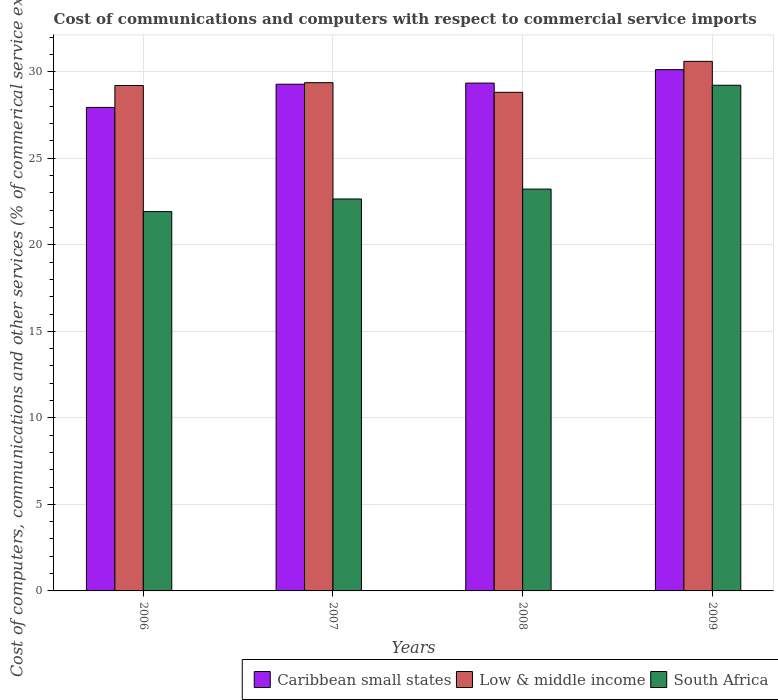Are the number of bars per tick equal to the number of legend labels?
Keep it short and to the point. Yes. Are the number of bars on each tick of the X-axis equal?
Make the answer very short. Yes. How many bars are there on the 1st tick from the left?
Ensure brevity in your answer.  3. How many bars are there on the 2nd tick from the right?
Your response must be concise. 3. What is the cost of communications and computers in South Africa in 2008?
Keep it short and to the point. 23.22. Across all years, what is the maximum cost of communications and computers in Low & middle income?
Provide a short and direct response. 30.6. Across all years, what is the minimum cost of communications and computers in South Africa?
Provide a short and direct response. 21.92. In which year was the cost of communications and computers in Caribbean small states maximum?
Offer a very short reply. 2009. What is the total cost of communications and computers in Caribbean small states in the graph?
Offer a very short reply. 116.67. What is the difference between the cost of communications and computers in Low & middle income in 2007 and that in 2009?
Your response must be concise. -1.23. What is the difference between the cost of communications and computers in Low & middle income in 2008 and the cost of communications and computers in South Africa in 2009?
Provide a succinct answer. -0.41. What is the average cost of communications and computers in Caribbean small states per year?
Offer a very short reply. 29.17. In the year 2009, what is the difference between the cost of communications and computers in Caribbean small states and cost of communications and computers in South Africa?
Your response must be concise. 0.9. In how many years, is the cost of communications and computers in Low & middle income greater than 15 %?
Provide a succinct answer. 4. What is the ratio of the cost of communications and computers in Low & middle income in 2007 to that in 2008?
Provide a succinct answer. 1.02. What is the difference between the highest and the second highest cost of communications and computers in South Africa?
Ensure brevity in your answer.  6. What is the difference between the highest and the lowest cost of communications and computers in Low & middle income?
Your answer should be compact. 1.79. What does the 3rd bar from the left in 2008 represents?
Make the answer very short. South Africa. What does the 1st bar from the right in 2007 represents?
Your response must be concise. South Africa. Is it the case that in every year, the sum of the cost of communications and computers in Low & middle income and cost of communications and computers in South Africa is greater than the cost of communications and computers in Caribbean small states?
Offer a very short reply. Yes. How many bars are there?
Keep it short and to the point. 12. Are all the bars in the graph horizontal?
Ensure brevity in your answer.  No. How many years are there in the graph?
Your answer should be compact. 4. What is the difference between two consecutive major ticks on the Y-axis?
Ensure brevity in your answer.  5. Are the values on the major ticks of Y-axis written in scientific E-notation?
Offer a terse response. No. Does the graph contain grids?
Offer a very short reply. Yes. Where does the legend appear in the graph?
Your response must be concise. Bottom right. How many legend labels are there?
Provide a succinct answer. 3. What is the title of the graph?
Offer a terse response. Cost of communications and computers with respect to commercial service imports. Does "Iceland" appear as one of the legend labels in the graph?
Provide a short and direct response. No. What is the label or title of the X-axis?
Your answer should be compact. Years. What is the label or title of the Y-axis?
Your answer should be very brief. Cost of computers, communications and other services (% of commerical service exports). What is the Cost of computers, communications and other services (% of commerical service exports) in Caribbean small states in 2006?
Your response must be concise. 27.94. What is the Cost of computers, communications and other services (% of commerical service exports) of Low & middle income in 2006?
Provide a succinct answer. 29.2. What is the Cost of computers, communications and other services (% of commerical service exports) in South Africa in 2006?
Give a very brief answer. 21.92. What is the Cost of computers, communications and other services (% of commerical service exports) of Caribbean small states in 2007?
Your response must be concise. 29.28. What is the Cost of computers, communications and other services (% of commerical service exports) of Low & middle income in 2007?
Ensure brevity in your answer.  29.37. What is the Cost of computers, communications and other services (% of commerical service exports) of South Africa in 2007?
Give a very brief answer. 22.65. What is the Cost of computers, communications and other services (% of commerical service exports) of Caribbean small states in 2008?
Give a very brief answer. 29.34. What is the Cost of computers, communications and other services (% of commerical service exports) in Low & middle income in 2008?
Keep it short and to the point. 28.81. What is the Cost of computers, communications and other services (% of commerical service exports) of South Africa in 2008?
Provide a succinct answer. 23.22. What is the Cost of computers, communications and other services (% of commerical service exports) in Caribbean small states in 2009?
Give a very brief answer. 30.12. What is the Cost of computers, communications and other services (% of commerical service exports) in Low & middle income in 2009?
Your answer should be compact. 30.6. What is the Cost of computers, communications and other services (% of commerical service exports) of South Africa in 2009?
Your answer should be compact. 29.22. Across all years, what is the maximum Cost of computers, communications and other services (% of commerical service exports) in Caribbean small states?
Provide a short and direct response. 30.12. Across all years, what is the maximum Cost of computers, communications and other services (% of commerical service exports) of Low & middle income?
Your response must be concise. 30.6. Across all years, what is the maximum Cost of computers, communications and other services (% of commerical service exports) in South Africa?
Offer a very short reply. 29.22. Across all years, what is the minimum Cost of computers, communications and other services (% of commerical service exports) of Caribbean small states?
Your answer should be compact. 27.94. Across all years, what is the minimum Cost of computers, communications and other services (% of commerical service exports) in Low & middle income?
Your answer should be compact. 28.81. Across all years, what is the minimum Cost of computers, communications and other services (% of commerical service exports) of South Africa?
Make the answer very short. 21.92. What is the total Cost of computers, communications and other services (% of commerical service exports) of Caribbean small states in the graph?
Your answer should be compact. 116.67. What is the total Cost of computers, communications and other services (% of commerical service exports) in Low & middle income in the graph?
Provide a short and direct response. 117.97. What is the total Cost of computers, communications and other services (% of commerical service exports) of South Africa in the graph?
Make the answer very short. 97. What is the difference between the Cost of computers, communications and other services (% of commerical service exports) of Caribbean small states in 2006 and that in 2007?
Offer a terse response. -1.34. What is the difference between the Cost of computers, communications and other services (% of commerical service exports) in Low & middle income in 2006 and that in 2007?
Your response must be concise. -0.16. What is the difference between the Cost of computers, communications and other services (% of commerical service exports) of South Africa in 2006 and that in 2007?
Your response must be concise. -0.73. What is the difference between the Cost of computers, communications and other services (% of commerical service exports) of Caribbean small states in 2006 and that in 2008?
Give a very brief answer. -1.41. What is the difference between the Cost of computers, communications and other services (% of commerical service exports) in Low & middle income in 2006 and that in 2008?
Keep it short and to the point. 0.39. What is the difference between the Cost of computers, communications and other services (% of commerical service exports) of South Africa in 2006 and that in 2008?
Your answer should be compact. -1.3. What is the difference between the Cost of computers, communications and other services (% of commerical service exports) in Caribbean small states in 2006 and that in 2009?
Offer a terse response. -2.18. What is the difference between the Cost of computers, communications and other services (% of commerical service exports) of Low & middle income in 2006 and that in 2009?
Make the answer very short. -1.4. What is the difference between the Cost of computers, communications and other services (% of commerical service exports) of South Africa in 2006 and that in 2009?
Keep it short and to the point. -7.3. What is the difference between the Cost of computers, communications and other services (% of commerical service exports) in Caribbean small states in 2007 and that in 2008?
Your answer should be very brief. -0.06. What is the difference between the Cost of computers, communications and other services (% of commerical service exports) in Low & middle income in 2007 and that in 2008?
Keep it short and to the point. 0.56. What is the difference between the Cost of computers, communications and other services (% of commerical service exports) of South Africa in 2007 and that in 2008?
Provide a succinct answer. -0.57. What is the difference between the Cost of computers, communications and other services (% of commerical service exports) of Caribbean small states in 2007 and that in 2009?
Give a very brief answer. -0.84. What is the difference between the Cost of computers, communications and other services (% of commerical service exports) in Low & middle income in 2007 and that in 2009?
Offer a very short reply. -1.23. What is the difference between the Cost of computers, communications and other services (% of commerical service exports) of South Africa in 2007 and that in 2009?
Your response must be concise. -6.57. What is the difference between the Cost of computers, communications and other services (% of commerical service exports) of Caribbean small states in 2008 and that in 2009?
Your response must be concise. -0.78. What is the difference between the Cost of computers, communications and other services (% of commerical service exports) in Low & middle income in 2008 and that in 2009?
Provide a short and direct response. -1.79. What is the difference between the Cost of computers, communications and other services (% of commerical service exports) of South Africa in 2008 and that in 2009?
Your response must be concise. -6. What is the difference between the Cost of computers, communications and other services (% of commerical service exports) of Caribbean small states in 2006 and the Cost of computers, communications and other services (% of commerical service exports) of Low & middle income in 2007?
Offer a very short reply. -1.43. What is the difference between the Cost of computers, communications and other services (% of commerical service exports) in Caribbean small states in 2006 and the Cost of computers, communications and other services (% of commerical service exports) in South Africa in 2007?
Your answer should be compact. 5.29. What is the difference between the Cost of computers, communications and other services (% of commerical service exports) in Low & middle income in 2006 and the Cost of computers, communications and other services (% of commerical service exports) in South Africa in 2007?
Make the answer very short. 6.56. What is the difference between the Cost of computers, communications and other services (% of commerical service exports) in Caribbean small states in 2006 and the Cost of computers, communications and other services (% of commerical service exports) in Low & middle income in 2008?
Keep it short and to the point. -0.87. What is the difference between the Cost of computers, communications and other services (% of commerical service exports) in Caribbean small states in 2006 and the Cost of computers, communications and other services (% of commerical service exports) in South Africa in 2008?
Provide a short and direct response. 4.72. What is the difference between the Cost of computers, communications and other services (% of commerical service exports) of Low & middle income in 2006 and the Cost of computers, communications and other services (% of commerical service exports) of South Africa in 2008?
Provide a short and direct response. 5.98. What is the difference between the Cost of computers, communications and other services (% of commerical service exports) of Caribbean small states in 2006 and the Cost of computers, communications and other services (% of commerical service exports) of Low & middle income in 2009?
Keep it short and to the point. -2.66. What is the difference between the Cost of computers, communications and other services (% of commerical service exports) of Caribbean small states in 2006 and the Cost of computers, communications and other services (% of commerical service exports) of South Africa in 2009?
Your answer should be compact. -1.28. What is the difference between the Cost of computers, communications and other services (% of commerical service exports) of Low & middle income in 2006 and the Cost of computers, communications and other services (% of commerical service exports) of South Africa in 2009?
Give a very brief answer. -0.02. What is the difference between the Cost of computers, communications and other services (% of commerical service exports) in Caribbean small states in 2007 and the Cost of computers, communications and other services (% of commerical service exports) in Low & middle income in 2008?
Your answer should be very brief. 0.47. What is the difference between the Cost of computers, communications and other services (% of commerical service exports) in Caribbean small states in 2007 and the Cost of computers, communications and other services (% of commerical service exports) in South Africa in 2008?
Your response must be concise. 6.06. What is the difference between the Cost of computers, communications and other services (% of commerical service exports) of Low & middle income in 2007 and the Cost of computers, communications and other services (% of commerical service exports) of South Africa in 2008?
Your answer should be compact. 6.15. What is the difference between the Cost of computers, communications and other services (% of commerical service exports) of Caribbean small states in 2007 and the Cost of computers, communications and other services (% of commerical service exports) of Low & middle income in 2009?
Your answer should be compact. -1.32. What is the difference between the Cost of computers, communications and other services (% of commerical service exports) of Caribbean small states in 2007 and the Cost of computers, communications and other services (% of commerical service exports) of South Africa in 2009?
Keep it short and to the point. 0.06. What is the difference between the Cost of computers, communications and other services (% of commerical service exports) of Low & middle income in 2007 and the Cost of computers, communications and other services (% of commerical service exports) of South Africa in 2009?
Offer a terse response. 0.15. What is the difference between the Cost of computers, communications and other services (% of commerical service exports) of Caribbean small states in 2008 and the Cost of computers, communications and other services (% of commerical service exports) of Low & middle income in 2009?
Give a very brief answer. -1.26. What is the difference between the Cost of computers, communications and other services (% of commerical service exports) in Caribbean small states in 2008 and the Cost of computers, communications and other services (% of commerical service exports) in South Africa in 2009?
Give a very brief answer. 0.12. What is the difference between the Cost of computers, communications and other services (% of commerical service exports) in Low & middle income in 2008 and the Cost of computers, communications and other services (% of commerical service exports) in South Africa in 2009?
Your response must be concise. -0.41. What is the average Cost of computers, communications and other services (% of commerical service exports) in Caribbean small states per year?
Keep it short and to the point. 29.17. What is the average Cost of computers, communications and other services (% of commerical service exports) of Low & middle income per year?
Make the answer very short. 29.49. What is the average Cost of computers, communications and other services (% of commerical service exports) in South Africa per year?
Your response must be concise. 24.25. In the year 2006, what is the difference between the Cost of computers, communications and other services (% of commerical service exports) of Caribbean small states and Cost of computers, communications and other services (% of commerical service exports) of Low & middle income?
Your response must be concise. -1.27. In the year 2006, what is the difference between the Cost of computers, communications and other services (% of commerical service exports) in Caribbean small states and Cost of computers, communications and other services (% of commerical service exports) in South Africa?
Provide a succinct answer. 6.02. In the year 2006, what is the difference between the Cost of computers, communications and other services (% of commerical service exports) in Low & middle income and Cost of computers, communications and other services (% of commerical service exports) in South Africa?
Offer a terse response. 7.29. In the year 2007, what is the difference between the Cost of computers, communications and other services (% of commerical service exports) in Caribbean small states and Cost of computers, communications and other services (% of commerical service exports) in Low & middle income?
Offer a terse response. -0.09. In the year 2007, what is the difference between the Cost of computers, communications and other services (% of commerical service exports) of Caribbean small states and Cost of computers, communications and other services (% of commerical service exports) of South Africa?
Give a very brief answer. 6.63. In the year 2007, what is the difference between the Cost of computers, communications and other services (% of commerical service exports) in Low & middle income and Cost of computers, communications and other services (% of commerical service exports) in South Africa?
Your answer should be compact. 6.72. In the year 2008, what is the difference between the Cost of computers, communications and other services (% of commerical service exports) in Caribbean small states and Cost of computers, communications and other services (% of commerical service exports) in Low & middle income?
Provide a succinct answer. 0.53. In the year 2008, what is the difference between the Cost of computers, communications and other services (% of commerical service exports) in Caribbean small states and Cost of computers, communications and other services (% of commerical service exports) in South Africa?
Give a very brief answer. 6.12. In the year 2008, what is the difference between the Cost of computers, communications and other services (% of commerical service exports) in Low & middle income and Cost of computers, communications and other services (% of commerical service exports) in South Africa?
Offer a terse response. 5.59. In the year 2009, what is the difference between the Cost of computers, communications and other services (% of commerical service exports) of Caribbean small states and Cost of computers, communications and other services (% of commerical service exports) of Low & middle income?
Your answer should be very brief. -0.48. In the year 2009, what is the difference between the Cost of computers, communications and other services (% of commerical service exports) of Caribbean small states and Cost of computers, communications and other services (% of commerical service exports) of South Africa?
Ensure brevity in your answer.  0.9. In the year 2009, what is the difference between the Cost of computers, communications and other services (% of commerical service exports) of Low & middle income and Cost of computers, communications and other services (% of commerical service exports) of South Africa?
Offer a terse response. 1.38. What is the ratio of the Cost of computers, communications and other services (% of commerical service exports) of Caribbean small states in 2006 to that in 2007?
Offer a terse response. 0.95. What is the ratio of the Cost of computers, communications and other services (% of commerical service exports) in South Africa in 2006 to that in 2007?
Ensure brevity in your answer.  0.97. What is the ratio of the Cost of computers, communications and other services (% of commerical service exports) in Caribbean small states in 2006 to that in 2008?
Provide a short and direct response. 0.95. What is the ratio of the Cost of computers, communications and other services (% of commerical service exports) in Low & middle income in 2006 to that in 2008?
Make the answer very short. 1.01. What is the ratio of the Cost of computers, communications and other services (% of commerical service exports) of South Africa in 2006 to that in 2008?
Offer a terse response. 0.94. What is the ratio of the Cost of computers, communications and other services (% of commerical service exports) of Caribbean small states in 2006 to that in 2009?
Provide a succinct answer. 0.93. What is the ratio of the Cost of computers, communications and other services (% of commerical service exports) of Low & middle income in 2006 to that in 2009?
Offer a terse response. 0.95. What is the ratio of the Cost of computers, communications and other services (% of commerical service exports) of South Africa in 2006 to that in 2009?
Your answer should be very brief. 0.75. What is the ratio of the Cost of computers, communications and other services (% of commerical service exports) of Low & middle income in 2007 to that in 2008?
Your answer should be very brief. 1.02. What is the ratio of the Cost of computers, communications and other services (% of commerical service exports) in South Africa in 2007 to that in 2008?
Your answer should be compact. 0.98. What is the ratio of the Cost of computers, communications and other services (% of commerical service exports) in Caribbean small states in 2007 to that in 2009?
Offer a terse response. 0.97. What is the ratio of the Cost of computers, communications and other services (% of commerical service exports) of Low & middle income in 2007 to that in 2009?
Your response must be concise. 0.96. What is the ratio of the Cost of computers, communications and other services (% of commerical service exports) of South Africa in 2007 to that in 2009?
Your answer should be compact. 0.78. What is the ratio of the Cost of computers, communications and other services (% of commerical service exports) in Caribbean small states in 2008 to that in 2009?
Provide a short and direct response. 0.97. What is the ratio of the Cost of computers, communications and other services (% of commerical service exports) in Low & middle income in 2008 to that in 2009?
Provide a succinct answer. 0.94. What is the ratio of the Cost of computers, communications and other services (% of commerical service exports) in South Africa in 2008 to that in 2009?
Your answer should be very brief. 0.79. What is the difference between the highest and the second highest Cost of computers, communications and other services (% of commerical service exports) in Caribbean small states?
Offer a very short reply. 0.78. What is the difference between the highest and the second highest Cost of computers, communications and other services (% of commerical service exports) in Low & middle income?
Offer a terse response. 1.23. What is the difference between the highest and the second highest Cost of computers, communications and other services (% of commerical service exports) in South Africa?
Your response must be concise. 6. What is the difference between the highest and the lowest Cost of computers, communications and other services (% of commerical service exports) of Caribbean small states?
Your answer should be compact. 2.18. What is the difference between the highest and the lowest Cost of computers, communications and other services (% of commerical service exports) in Low & middle income?
Provide a short and direct response. 1.79. What is the difference between the highest and the lowest Cost of computers, communications and other services (% of commerical service exports) in South Africa?
Offer a terse response. 7.3. 